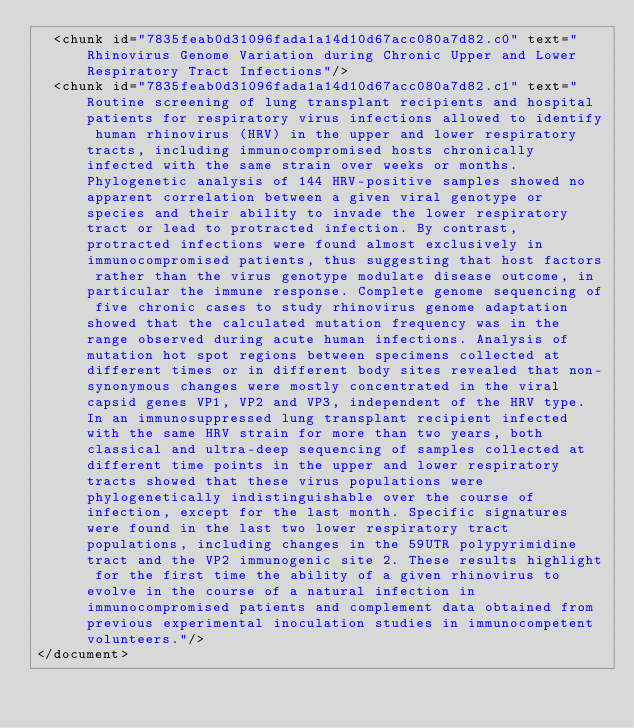Convert code to text. <code><loc_0><loc_0><loc_500><loc_500><_XML_>  <chunk id="7835feab0d31096fada1a14d10d67acc080a7d82.c0" text="Rhinovirus Genome Variation during Chronic Upper and Lower Respiratory Tract Infections"/>
  <chunk id="7835feab0d31096fada1a14d10d67acc080a7d82.c1" text="Routine screening of lung transplant recipients and hospital patients for respiratory virus infections allowed to identify human rhinovirus (HRV) in the upper and lower respiratory tracts, including immunocompromised hosts chronically infected with the same strain over weeks or months. Phylogenetic analysis of 144 HRV-positive samples showed no apparent correlation between a given viral genotype or species and their ability to invade the lower respiratory tract or lead to protracted infection. By contrast, protracted infections were found almost exclusively in immunocompromised patients, thus suggesting that host factors rather than the virus genotype modulate disease outcome, in particular the immune response. Complete genome sequencing of five chronic cases to study rhinovirus genome adaptation showed that the calculated mutation frequency was in the range observed during acute human infections. Analysis of mutation hot spot regions between specimens collected at different times or in different body sites revealed that non-synonymous changes were mostly concentrated in the viral capsid genes VP1, VP2 and VP3, independent of the HRV type. In an immunosuppressed lung transplant recipient infected with the same HRV strain for more than two years, both classical and ultra-deep sequencing of samples collected at different time points in the upper and lower respiratory tracts showed that these virus populations were phylogenetically indistinguishable over the course of infection, except for the last month. Specific signatures were found in the last two lower respiratory tract populations, including changes in the 59UTR polypyrimidine tract and the VP2 immunogenic site 2. These results highlight for the first time the ability of a given rhinovirus to evolve in the course of a natural infection in immunocompromised patients and complement data obtained from previous experimental inoculation studies in immunocompetent volunteers."/>
</document>
</code> 